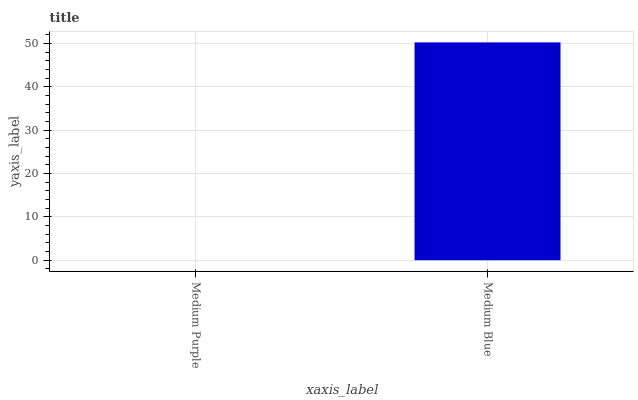Is Medium Blue the minimum?
Answer yes or no. No. Is Medium Blue greater than Medium Purple?
Answer yes or no. Yes. Is Medium Purple less than Medium Blue?
Answer yes or no. Yes. Is Medium Purple greater than Medium Blue?
Answer yes or no. No. Is Medium Blue less than Medium Purple?
Answer yes or no. No. Is Medium Blue the high median?
Answer yes or no. Yes. Is Medium Purple the low median?
Answer yes or no. Yes. Is Medium Purple the high median?
Answer yes or no. No. Is Medium Blue the low median?
Answer yes or no. No. 